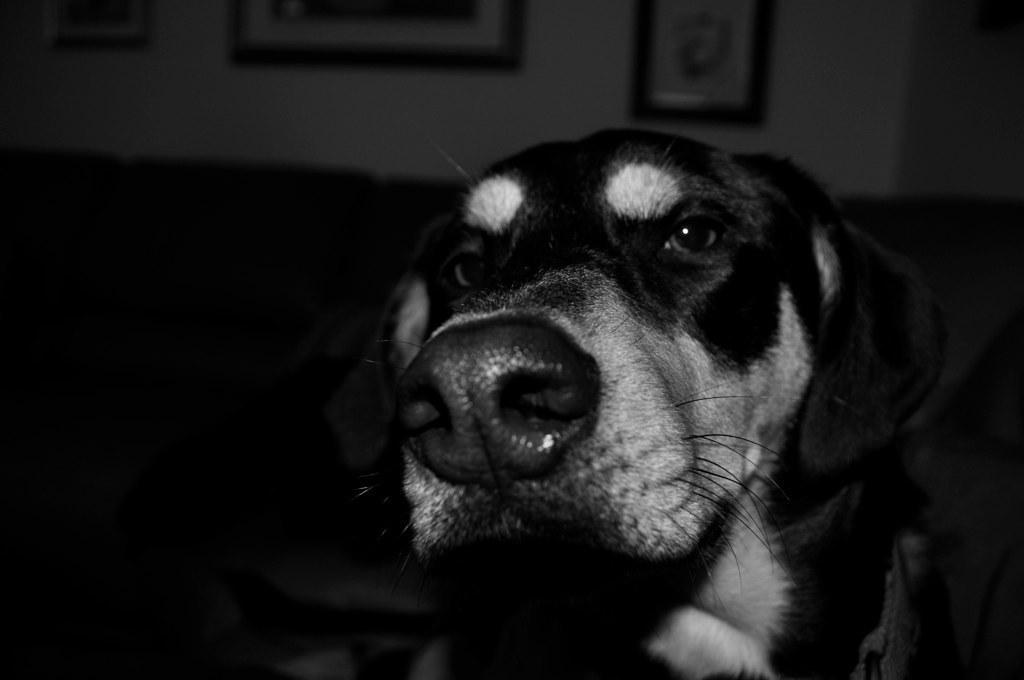In one or two sentences, can you explain what this image depicts? It is a black and white picture. In the center of the image we can see one dog, which is in black and white color. In the background there is a wall, photo frames and a few other objects. 